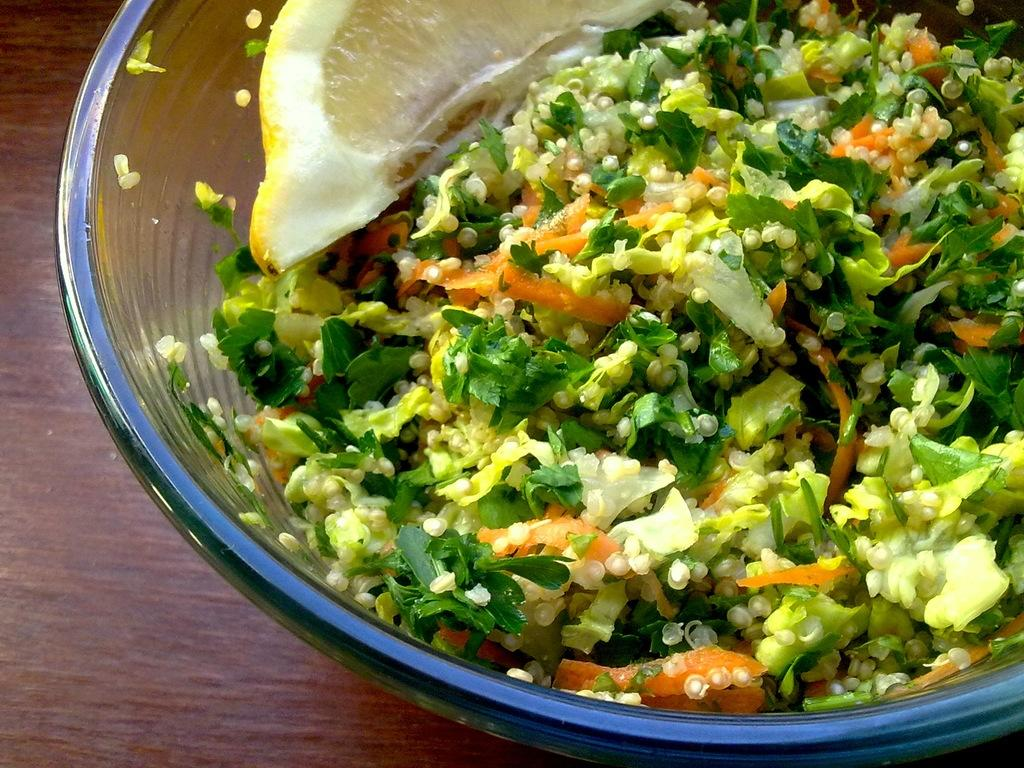What type of food can be seen in the image? There is a food item in a glass bowl in the image. What colors are present in the food? The food has colors: white, yellow, green, and orange. On what surface is the bowl placed? The bowl is on a brown-colored table. Where is the stomach located in the image? There is no stomach present in the image; it is a picture of a food item in a glass bowl on a brown-colored table. 